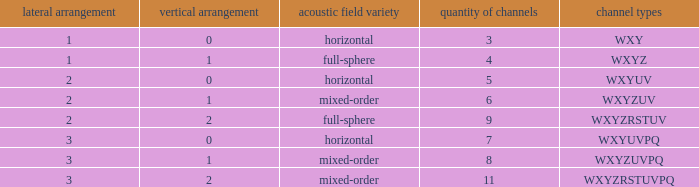If the height order is 1 and the soundfield type is mixed-order, what are all the channels? WXYZUV, WXYZUVPQ. 